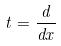<formula> <loc_0><loc_0><loc_500><loc_500>t = \frac { d } { d x }</formula> 